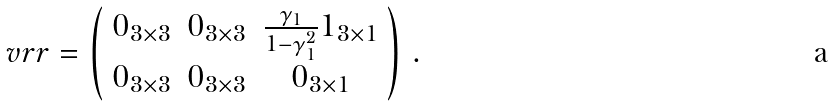<formula> <loc_0><loc_0><loc_500><loc_500>\ v r r = \left ( \begin{array} { c c c } 0 _ { 3 \times 3 } & 0 _ { 3 \times 3 } & \frac { \gamma _ { 1 } } { 1 - \gamma _ { 1 } ^ { 2 } } 1 _ { 3 \times 1 } \\ 0 _ { 3 \times 3 } & 0 _ { 3 \times 3 } & 0 _ { 3 \times 1 } \end{array} \right ) \, .</formula> 